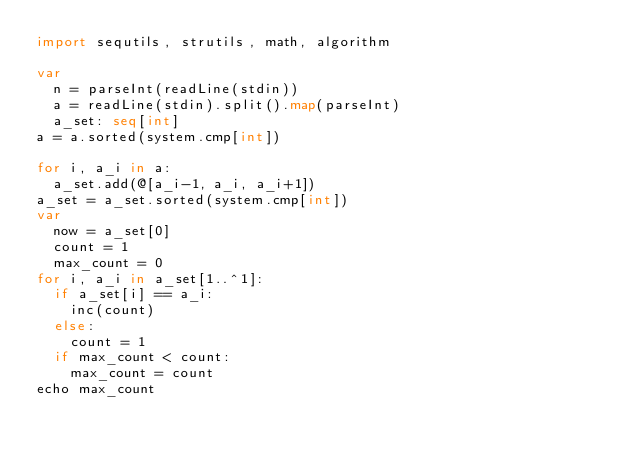Convert code to text. <code><loc_0><loc_0><loc_500><loc_500><_Nim_>import sequtils, strutils, math, algorithm

var
  n = parseInt(readLine(stdin))
  a = readLine(stdin).split().map(parseInt)
  a_set: seq[int]
a = a.sorted(system.cmp[int])

for i, a_i in a:
  a_set.add(@[a_i-1, a_i, a_i+1])
a_set = a_set.sorted(system.cmp[int])
var
  now = a_set[0]
  count = 1
  max_count = 0
for i, a_i in a_set[1..^1]:
  if a_set[i] == a_i:
    inc(count)
  else:
    count = 1
  if max_count < count:
    max_count = count
echo max_count</code> 